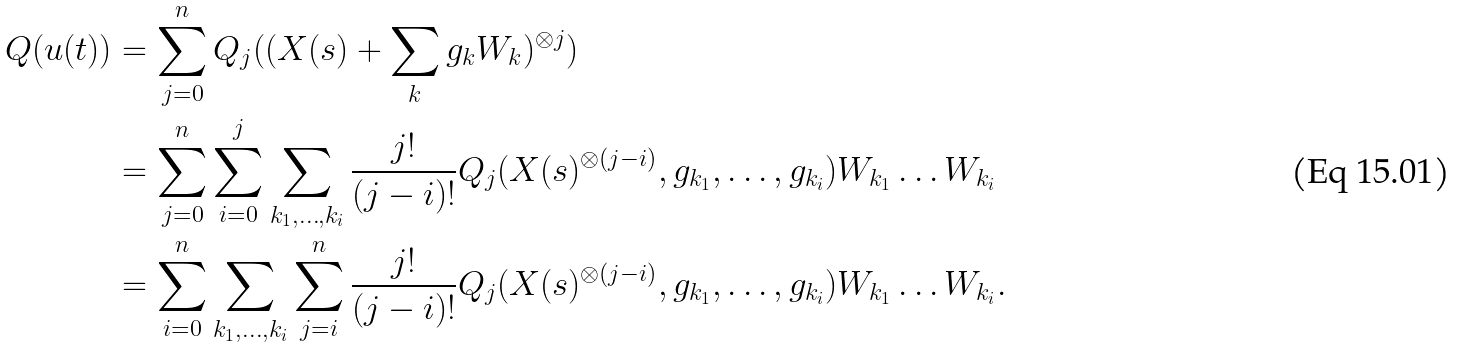<formula> <loc_0><loc_0><loc_500><loc_500>Q ( u ( t ) ) & = \sum _ { j = 0 } ^ { n } Q _ { j } ( ( X ( s ) + \sum _ { k } g _ { k } W _ { k } ) ^ { \otimes j } ) \\ & = \sum _ { j = 0 } ^ { n } \sum _ { i = 0 } ^ { j } \sum _ { k _ { 1 } , \dots , k _ { i } } \frac { j ! } { ( j - i ) ! } Q _ { j } ( X ( s ) ^ { \otimes ( j - i ) } , g _ { k _ { 1 } } , \dots , g _ { k _ { i } } ) W _ { k _ { 1 } } \dots W _ { k _ { i } } \\ & = \sum _ { i = 0 } ^ { n } \sum _ { k _ { 1 } , \dots , k _ { i } } \sum _ { j = i } ^ { n } \frac { j ! } { ( j - i ) ! } Q _ { j } ( X ( s ) ^ { \otimes ( j - i ) } , g _ { k _ { 1 } } , \dots , g _ { k _ { i } } ) W _ { k _ { 1 } } \dots W _ { k _ { i } } .</formula> 